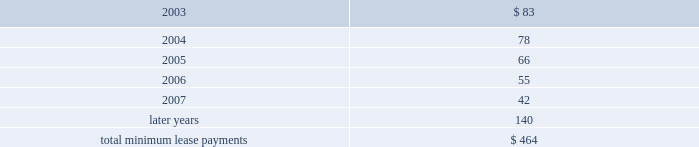Leases , was $ 92 million , $ 80 million , and $ 72 million in 2002 , 2001 , and 2000 , respectively .
Future minimum lease payments under noncancelable operating leases having remaining terms in excess of one year as of september 28 , 2002 , are as follows ( in millions ) : concentrations in the available sources of supply of materials and product although certain components essential to the company's business are generally available from multiple sources , other key components ( including microprocessors and application-specific integrated circuits , or ( "asics" ) ) are currently obtained by the company from single or limited sources .
Some other key components , while currently available to the company from multiple sources , are at times subject to industry- wide availability and pricing pressures .
In addition , the company uses some components that are not common to the rest of the personal computer industry , and new products introduced by the company often initially utilize custom components obtained from only one source until the company has evaluated whether there is a need for and subsequently qualifies additional suppliers .
If the supply of a key single-sourced component to the company were to be delayed or curtailed or in the event a key manufacturing vendor delays shipments of completed products to the company , the company's ability to ship related products in desired quantities and in a timely manner could be adversely affected .
The company's business and financial performance could also be adversely affected depending on the time required to obtain sufficient quantities from the original source , or to identify and obtain sufficient quantities from an alternative source .
Continued availability of these components may be affected if producers were to decide to concentrate on the production of common components instead of components customized to meet the company's requirements .
Finally , significant portions of the company's cpus , logic boards , and assembled products are now manufactured by outsourcing partners , the majority of which occurs in various parts of asia .
Although the company works closely with its outsourcing partners on manufacturing schedules and levels , the company's operating results could be adversely affected if its outsourcing partners were unable to meet their production obligations .
Contingencies beginning on september 27 , 2001 , three shareholder class action lawsuits were filed in the united states district court for the northern district of california against the company and its chief executive officer .
These lawsuits are substantially identical , and purport to bring suit on behalf of persons who purchased the company's publicly traded common stock between july 19 , 2000 , and september 28 , 2000 .
The complaints allege violations of the 1934 securities exchange act and seek unspecified compensatory damages and other relief .
The company believes these claims are without merit and intends to defend them vigorously .
The company filed a motion to dismiss on june 4 , 2002 , which was heard by the court on september 13 , 2002 .
On december 11 , 2002 , the court granted the company's motion to dismiss for failure to state a cause of action , with leave to plaintiffs to amend their complaint within thirty days .
The company is subject to certain other legal proceedings and claims that have arisen in the ordinary course of business and have not been fully adjudicated .
In the opinion of management , the company does not have a potential liability related to any current legal proceedings and claims that would have a material adverse effect on its financial condition , liquidity or results of operations .
However , the results of legal proceedings cannot be predicted with certainty .
Should the company fail to prevail in any of these legal matters or should several of these legal matters be resolved against the company in the same reporting period , the operating results of a particular reporting period could be materially adversely affected .
The parliament of the european union is working on finalizing the waste electrical and electronic equipment directive ( the directive ) .
The directive makes producers of electrical goods , including personal computers , financially responsible for the collection , recycling , and safe disposal of past and future products .
The directive must now be approved and implemented by individual european union governments by june 2004 , while the producers' financial obligations are scheduled to start june 2005 .
The company's potential liability resulting from the directive related to past sales of its products and expenses associated with future sales of its product may be substantial .
However , because it is likely that specific laws , regulations , and enforcement policies will vary significantly between individual european member states , it is not currently possible to estimate the company's existing liability or future expenses resulting from the directive .
As the european union and its individual member states clarify specific requirements and policies with respect to the directive , the company will continue to assess its potential financial impact .
Similar legislation may be enacted in other geographies , including federal and state legislation in the united states , the cumulative impact of which could be significant .
Fiscal years .

What percentage of total minimum lease payments is due in 2004? 
Computations: (78 / 464)
Answer: 0.1681. Leases , was $ 92 million , $ 80 million , and $ 72 million in 2002 , 2001 , and 2000 , respectively .
Future minimum lease payments under noncancelable operating leases having remaining terms in excess of one year as of september 28 , 2002 , are as follows ( in millions ) : concentrations in the available sources of supply of materials and product although certain components essential to the company's business are generally available from multiple sources , other key components ( including microprocessors and application-specific integrated circuits , or ( "asics" ) ) are currently obtained by the company from single or limited sources .
Some other key components , while currently available to the company from multiple sources , are at times subject to industry- wide availability and pricing pressures .
In addition , the company uses some components that are not common to the rest of the personal computer industry , and new products introduced by the company often initially utilize custom components obtained from only one source until the company has evaluated whether there is a need for and subsequently qualifies additional suppliers .
If the supply of a key single-sourced component to the company were to be delayed or curtailed or in the event a key manufacturing vendor delays shipments of completed products to the company , the company's ability to ship related products in desired quantities and in a timely manner could be adversely affected .
The company's business and financial performance could also be adversely affected depending on the time required to obtain sufficient quantities from the original source , or to identify and obtain sufficient quantities from an alternative source .
Continued availability of these components may be affected if producers were to decide to concentrate on the production of common components instead of components customized to meet the company's requirements .
Finally , significant portions of the company's cpus , logic boards , and assembled products are now manufactured by outsourcing partners , the majority of which occurs in various parts of asia .
Although the company works closely with its outsourcing partners on manufacturing schedules and levels , the company's operating results could be adversely affected if its outsourcing partners were unable to meet their production obligations .
Contingencies beginning on september 27 , 2001 , three shareholder class action lawsuits were filed in the united states district court for the northern district of california against the company and its chief executive officer .
These lawsuits are substantially identical , and purport to bring suit on behalf of persons who purchased the company's publicly traded common stock between july 19 , 2000 , and september 28 , 2000 .
The complaints allege violations of the 1934 securities exchange act and seek unspecified compensatory damages and other relief .
The company believes these claims are without merit and intends to defend them vigorously .
The company filed a motion to dismiss on june 4 , 2002 , which was heard by the court on september 13 , 2002 .
On december 11 , 2002 , the court granted the company's motion to dismiss for failure to state a cause of action , with leave to plaintiffs to amend their complaint within thirty days .
The company is subject to certain other legal proceedings and claims that have arisen in the ordinary course of business and have not been fully adjudicated .
In the opinion of management , the company does not have a potential liability related to any current legal proceedings and claims that would have a material adverse effect on its financial condition , liquidity or results of operations .
However , the results of legal proceedings cannot be predicted with certainty .
Should the company fail to prevail in any of these legal matters or should several of these legal matters be resolved against the company in the same reporting period , the operating results of a particular reporting period could be materially adversely affected .
The parliament of the european union is working on finalizing the waste electrical and electronic equipment directive ( the directive ) .
The directive makes producers of electrical goods , including personal computers , financially responsible for the collection , recycling , and safe disposal of past and future products .
The directive must now be approved and implemented by individual european union governments by june 2004 , while the producers' financial obligations are scheduled to start june 2005 .
The company's potential liability resulting from the directive related to past sales of its products and expenses associated with future sales of its product may be substantial .
However , because it is likely that specific laws , regulations , and enforcement policies will vary significantly between individual european member states , it is not currently possible to estimate the company's existing liability or future expenses resulting from the directive .
As the european union and its individual member states clarify specific requirements and policies with respect to the directive , the company will continue to assess its potential financial impact .
Similar legislation may be enacted in other geographies , including federal and state legislation in the united states , the cumulative impact of which could be significant .
Fiscal years .

What was the increase in total minimum lease payments between 2006 and 2007 in millions? 
Computations: (55 - 42)
Answer: 13.0. Leases , was $ 92 million , $ 80 million , and $ 72 million in 2002 , 2001 , and 2000 , respectively .
Future minimum lease payments under noncancelable operating leases having remaining terms in excess of one year as of september 28 , 2002 , are as follows ( in millions ) : concentrations in the available sources of supply of materials and product although certain components essential to the company's business are generally available from multiple sources , other key components ( including microprocessors and application-specific integrated circuits , or ( "asics" ) ) are currently obtained by the company from single or limited sources .
Some other key components , while currently available to the company from multiple sources , are at times subject to industry- wide availability and pricing pressures .
In addition , the company uses some components that are not common to the rest of the personal computer industry , and new products introduced by the company often initially utilize custom components obtained from only one source until the company has evaluated whether there is a need for and subsequently qualifies additional suppliers .
If the supply of a key single-sourced component to the company were to be delayed or curtailed or in the event a key manufacturing vendor delays shipments of completed products to the company , the company's ability to ship related products in desired quantities and in a timely manner could be adversely affected .
The company's business and financial performance could also be adversely affected depending on the time required to obtain sufficient quantities from the original source , or to identify and obtain sufficient quantities from an alternative source .
Continued availability of these components may be affected if producers were to decide to concentrate on the production of common components instead of components customized to meet the company's requirements .
Finally , significant portions of the company's cpus , logic boards , and assembled products are now manufactured by outsourcing partners , the majority of which occurs in various parts of asia .
Although the company works closely with its outsourcing partners on manufacturing schedules and levels , the company's operating results could be adversely affected if its outsourcing partners were unable to meet their production obligations .
Contingencies beginning on september 27 , 2001 , three shareholder class action lawsuits were filed in the united states district court for the northern district of california against the company and its chief executive officer .
These lawsuits are substantially identical , and purport to bring suit on behalf of persons who purchased the company's publicly traded common stock between july 19 , 2000 , and september 28 , 2000 .
The complaints allege violations of the 1934 securities exchange act and seek unspecified compensatory damages and other relief .
The company believes these claims are without merit and intends to defend them vigorously .
The company filed a motion to dismiss on june 4 , 2002 , which was heard by the court on september 13 , 2002 .
On december 11 , 2002 , the court granted the company's motion to dismiss for failure to state a cause of action , with leave to plaintiffs to amend their complaint within thirty days .
The company is subject to certain other legal proceedings and claims that have arisen in the ordinary course of business and have not been fully adjudicated .
In the opinion of management , the company does not have a potential liability related to any current legal proceedings and claims that would have a material adverse effect on its financial condition , liquidity or results of operations .
However , the results of legal proceedings cannot be predicted with certainty .
Should the company fail to prevail in any of these legal matters or should several of these legal matters be resolved against the company in the same reporting period , the operating results of a particular reporting period could be materially adversely affected .
The parliament of the european union is working on finalizing the waste electrical and electronic equipment directive ( the directive ) .
The directive makes producers of electrical goods , including personal computers , financially responsible for the collection , recycling , and safe disposal of past and future products .
The directive must now be approved and implemented by individual european union governments by june 2004 , while the producers' financial obligations are scheduled to start june 2005 .
The company's potential liability resulting from the directive related to past sales of its products and expenses associated with future sales of its product may be substantial .
However , because it is likely that specific laws , regulations , and enforcement policies will vary significantly between individual european member states , it is not currently possible to estimate the company's existing liability or future expenses resulting from the directive .
As the european union and its individual member states clarify specific requirements and policies with respect to the directive , the company will continue to assess its potential financial impact .
Similar legislation may be enacted in other geographies , including federal and state legislation in the united states , the cumulative impact of which could be significant .
Fiscal years .

What was the increase in total minimum lease payments between 2003 and 2004 in millions? 
Computations: (78 - 83)
Answer: -5.0. Leases , was $ 92 million , $ 80 million , and $ 72 million in 2002 , 2001 , and 2000 , respectively .
Future minimum lease payments under noncancelable operating leases having remaining terms in excess of one year as of september 28 , 2002 , are as follows ( in millions ) : concentrations in the available sources of supply of materials and product although certain components essential to the company's business are generally available from multiple sources , other key components ( including microprocessors and application-specific integrated circuits , or ( "asics" ) ) are currently obtained by the company from single or limited sources .
Some other key components , while currently available to the company from multiple sources , are at times subject to industry- wide availability and pricing pressures .
In addition , the company uses some components that are not common to the rest of the personal computer industry , and new products introduced by the company often initially utilize custom components obtained from only one source until the company has evaluated whether there is a need for and subsequently qualifies additional suppliers .
If the supply of a key single-sourced component to the company were to be delayed or curtailed or in the event a key manufacturing vendor delays shipments of completed products to the company , the company's ability to ship related products in desired quantities and in a timely manner could be adversely affected .
The company's business and financial performance could also be adversely affected depending on the time required to obtain sufficient quantities from the original source , or to identify and obtain sufficient quantities from an alternative source .
Continued availability of these components may be affected if producers were to decide to concentrate on the production of common components instead of components customized to meet the company's requirements .
Finally , significant portions of the company's cpus , logic boards , and assembled products are now manufactured by outsourcing partners , the majority of which occurs in various parts of asia .
Although the company works closely with its outsourcing partners on manufacturing schedules and levels , the company's operating results could be adversely affected if its outsourcing partners were unable to meet their production obligations .
Contingencies beginning on september 27 , 2001 , three shareholder class action lawsuits were filed in the united states district court for the northern district of california against the company and its chief executive officer .
These lawsuits are substantially identical , and purport to bring suit on behalf of persons who purchased the company's publicly traded common stock between july 19 , 2000 , and september 28 , 2000 .
The complaints allege violations of the 1934 securities exchange act and seek unspecified compensatory damages and other relief .
The company believes these claims are without merit and intends to defend them vigorously .
The company filed a motion to dismiss on june 4 , 2002 , which was heard by the court on september 13 , 2002 .
On december 11 , 2002 , the court granted the company's motion to dismiss for failure to state a cause of action , with leave to plaintiffs to amend their complaint within thirty days .
The company is subject to certain other legal proceedings and claims that have arisen in the ordinary course of business and have not been fully adjudicated .
In the opinion of management , the company does not have a potential liability related to any current legal proceedings and claims that would have a material adverse effect on its financial condition , liquidity or results of operations .
However , the results of legal proceedings cannot be predicted with certainty .
Should the company fail to prevail in any of these legal matters or should several of these legal matters be resolved against the company in the same reporting period , the operating results of a particular reporting period could be materially adversely affected .
The parliament of the european union is working on finalizing the waste electrical and electronic equipment directive ( the directive ) .
The directive makes producers of electrical goods , including personal computers , financially responsible for the collection , recycling , and safe disposal of past and future products .
The directive must now be approved and implemented by individual european union governments by june 2004 , while the producers' financial obligations are scheduled to start june 2005 .
The company's potential liability resulting from the directive related to past sales of its products and expenses associated with future sales of its product may be substantial .
However , because it is likely that specific laws , regulations , and enforcement policies will vary significantly between individual european member states , it is not currently possible to estimate the company's existing liability or future expenses resulting from the directive .
As the european union and its individual member states clarify specific requirements and policies with respect to the directive , the company will continue to assess its potential financial impact .
Similar legislation may be enacted in other geographies , including federal and state legislation in the united states , the cumulative impact of which could be significant .
Fiscal years .

What percentage of total minimum lease payments is due after 2007? 
Computations: (140 / 464)
Answer: 0.30172. 